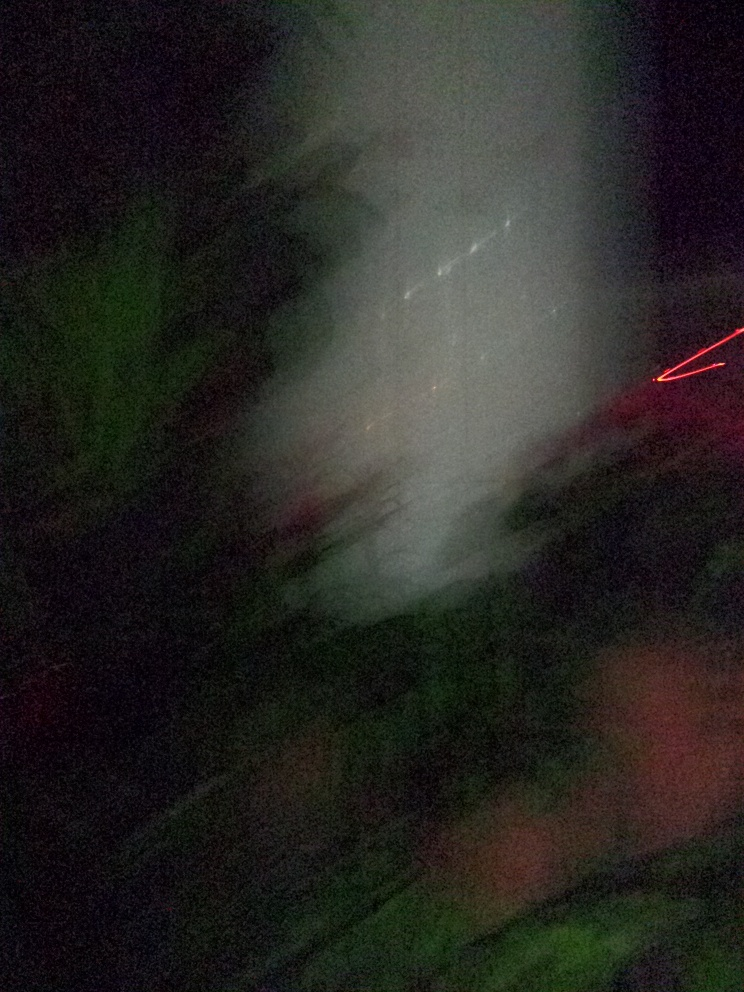What can you say about the quality of this image? The image is notably blurry and lacks clear details, giving an impression of motion or a low-light environment. It's hard to discern any specific subjects with certainty, which hampers the ability to accurately interpret or analyze the content of the photograph. This could result from a number of factors, such as camera shake during a long exposure, taking the photo while in motion, or possibly an intentional artistic choice to convey a sense of movement or abstraction. 